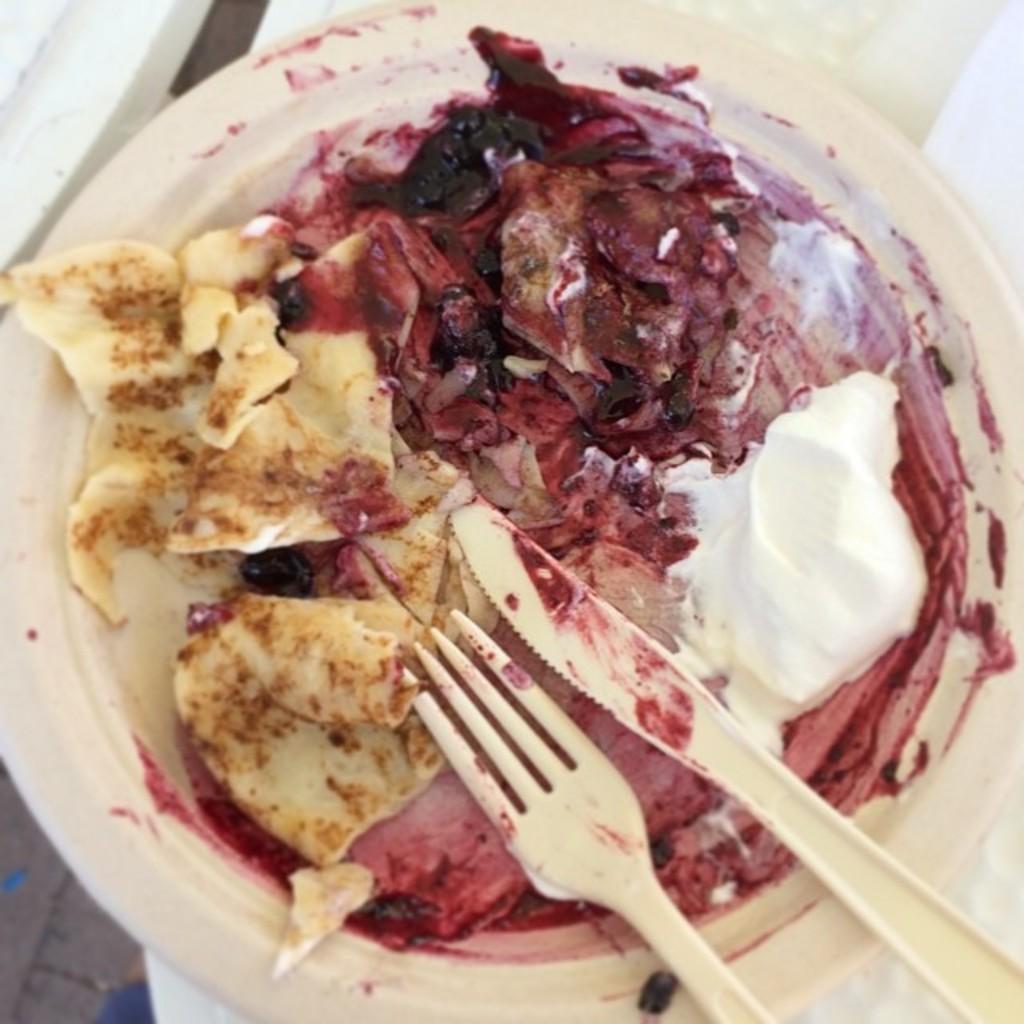Could you give a brief overview of what you see in this image? In this image we can see some food item which is in plate there is knife and fork in it. 